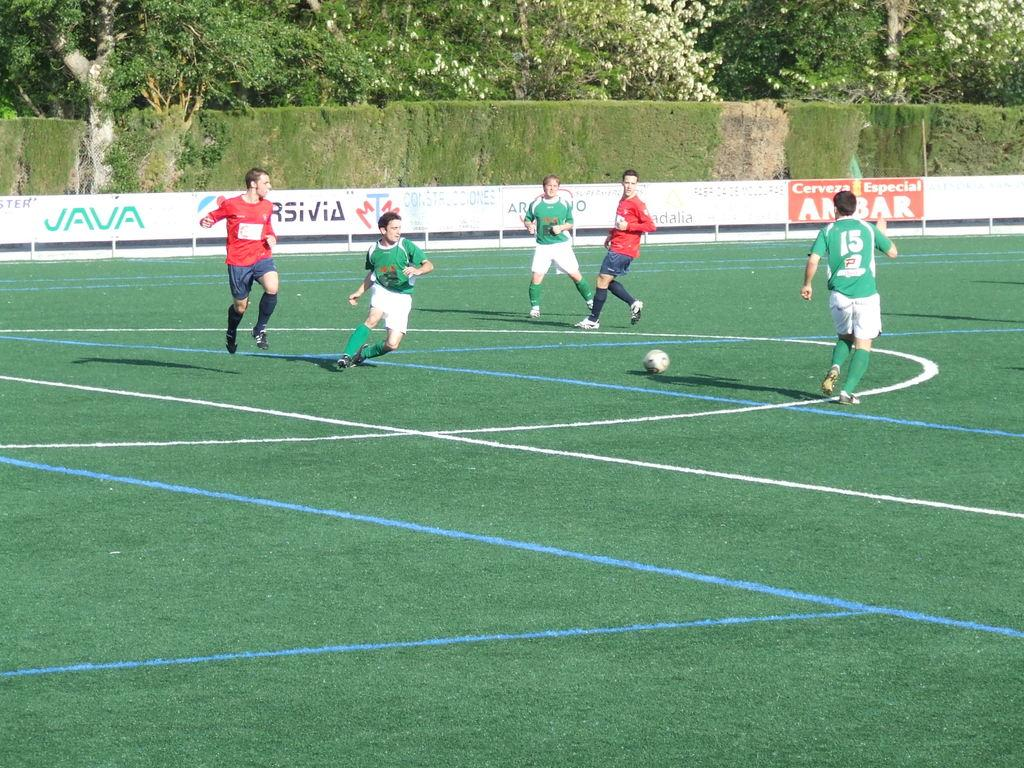<image>
Give a short and clear explanation of the subsequent image. A group of men are playing soccer in a field that says Java. 